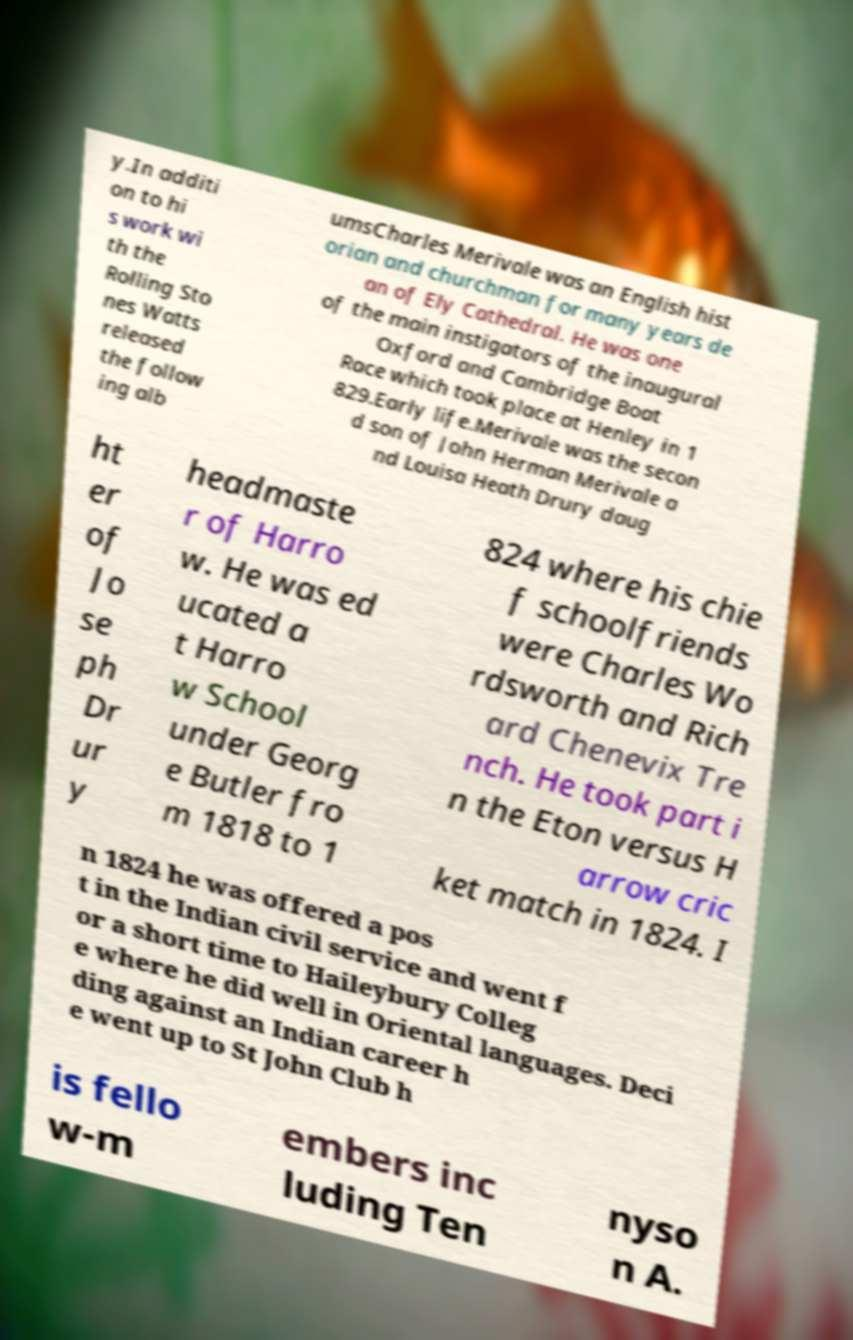Could you extract and type out the text from this image? y.In additi on to hi s work wi th the Rolling Sto nes Watts released the follow ing alb umsCharles Merivale was an English hist orian and churchman for many years de an of Ely Cathedral. He was one of the main instigators of the inaugural Oxford and Cambridge Boat Race which took place at Henley in 1 829.Early life.Merivale was the secon d son of John Herman Merivale a nd Louisa Heath Drury daug ht er of Jo se ph Dr ur y headmaste r of Harro w. He was ed ucated a t Harro w School under Georg e Butler fro m 1818 to 1 824 where his chie f schoolfriends were Charles Wo rdsworth and Rich ard Chenevix Tre nch. He took part i n the Eton versus H arrow cric ket match in 1824. I n 1824 he was offered a pos t in the Indian civil service and went f or a short time to Haileybury Colleg e where he did well in Oriental languages. Deci ding against an Indian career h e went up to St John Club h is fello w-m embers inc luding Ten nyso n A. 